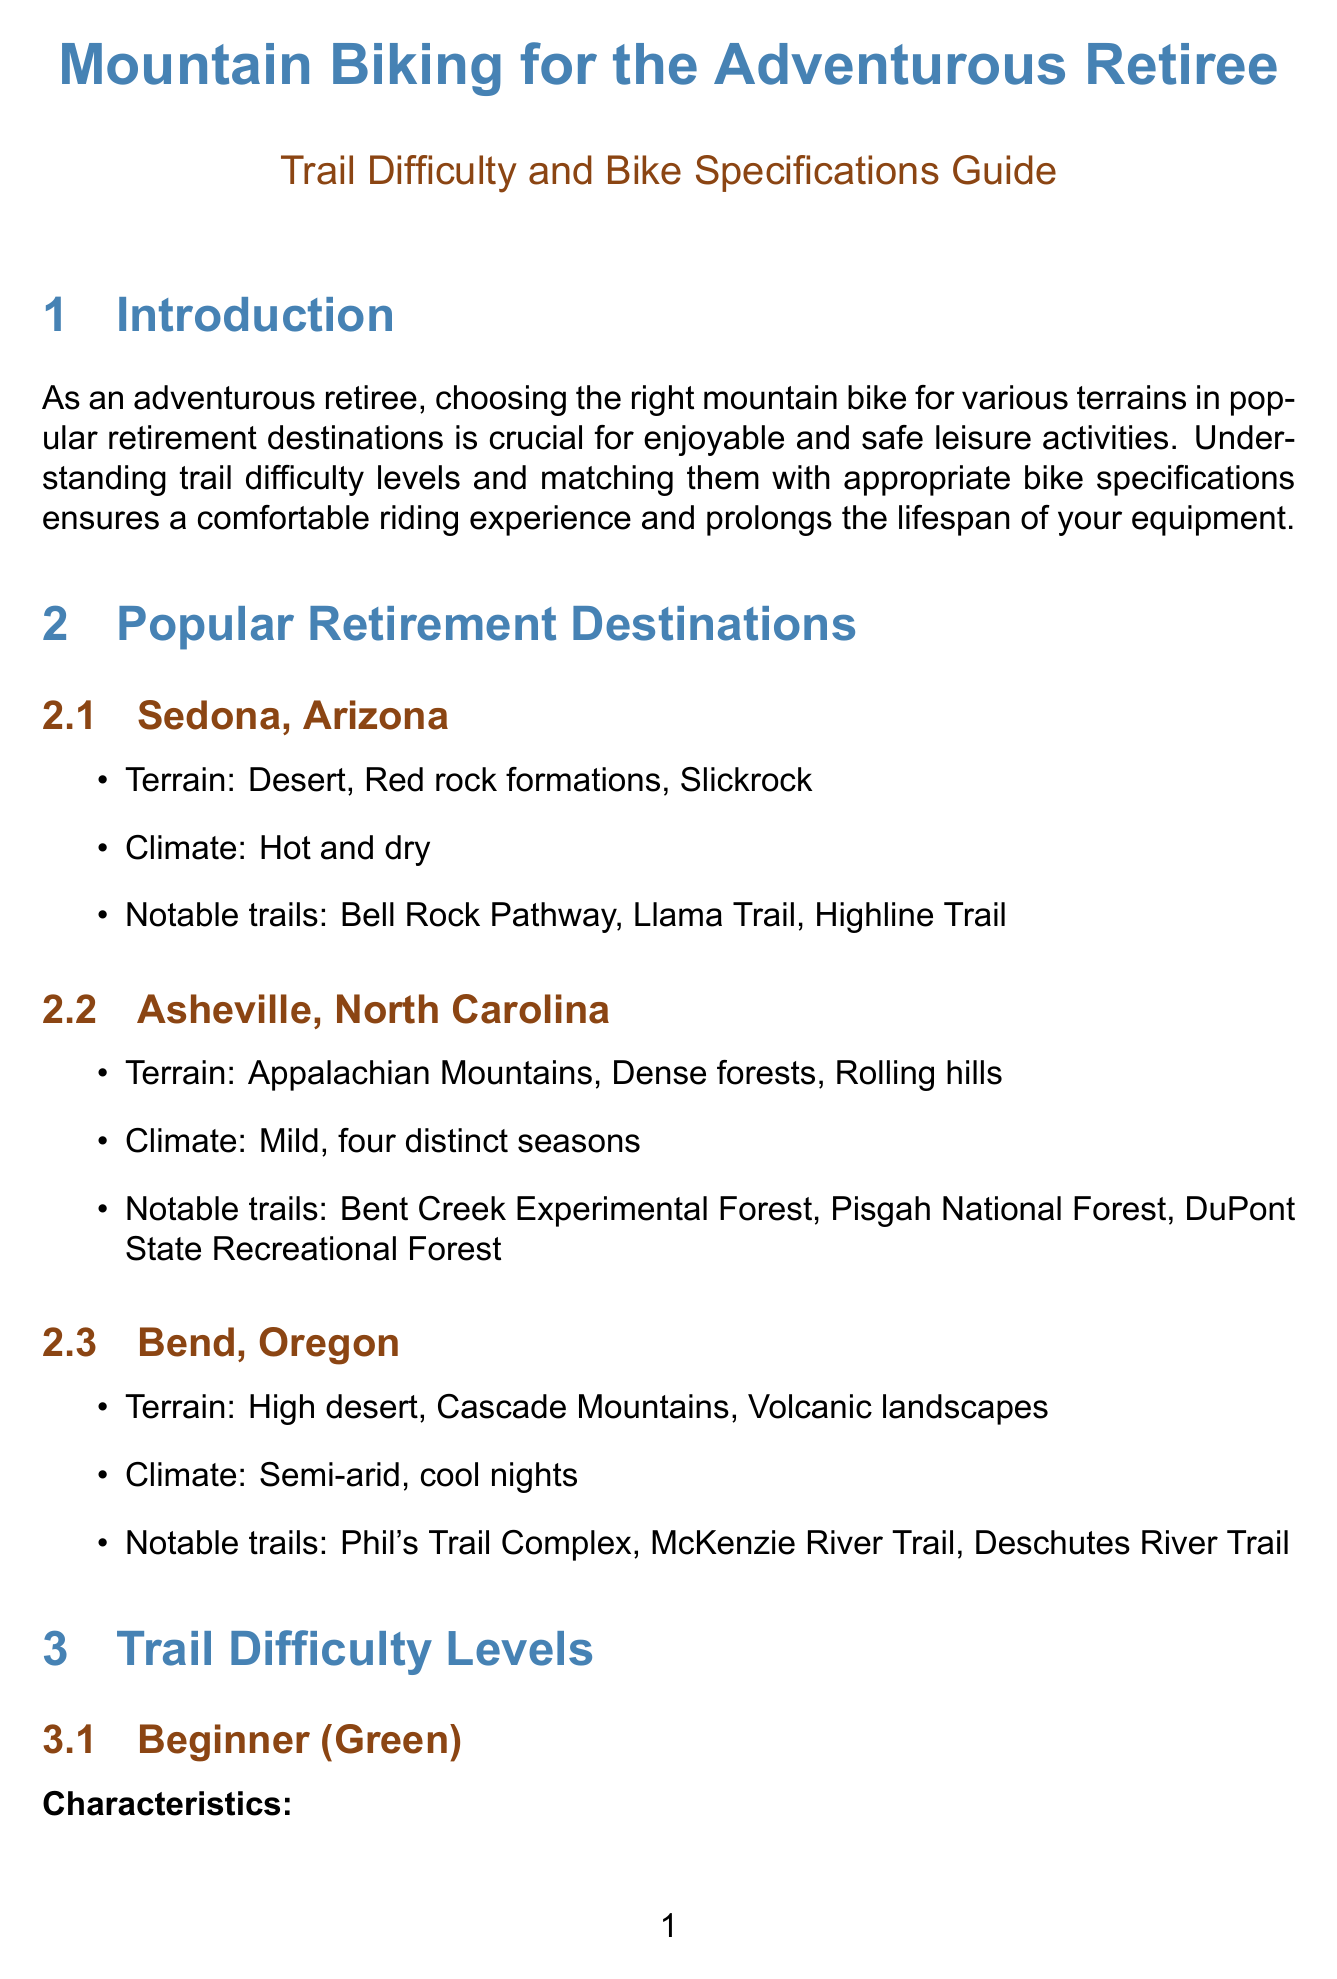What are the notable trails in Sedona, Arizona? The notable trails are listed in the section about Sedona, which includes Bell Rock Pathway, Llama Trail, and Highline Trail.
Answer: Bell Rock Pathway, Llama Trail, Highline Trail What is the recommended suspension for beginner trails? The recommended bike specifications for beginner trails state the suspension should be hardtail or full suspension with 100-120mm travel.
Answer: Hardtail or full suspension with 100-120mm travel Which bike brand features the model "Fuel EX 8"? The section detailing recommended bike brands specifies that Trek features the model Fuel EX 8.
Answer: Trek What characteristics define advanced (black) trails? The characteristics for advanced trails include steep challenging terrain, technical features, tight turns, and exposed sections with little room for error.
Answer: Steep challenging terrain, technical features, tight turns, exposed sections Which climate is associated with Asheville, North Carolina? The climate for Asheville, North Carolina is described in the document as mild with four distinct seasons.
Answer: Mild, four distinct seasons What is one of the safety considerations mentioned in the document? The safety considerations section includes various recommendations, one of which is always wearing a properly fitted helmet.
Answer: Always wear a properly fitted helmet What bike brand offers the "Rockhopper Comp 29"? The recommended bike brands section specifies that Specialized offers the model Rockhopper Comp 29.
Answer: Specialized What type of terrain is prominent in Bend, Oregon? The document outlines the terrain types in Bend, which include high desert, Cascade Mountains, and volcanic landscapes.
Answer: High desert, Cascade Mountains, volcanic landscapes 